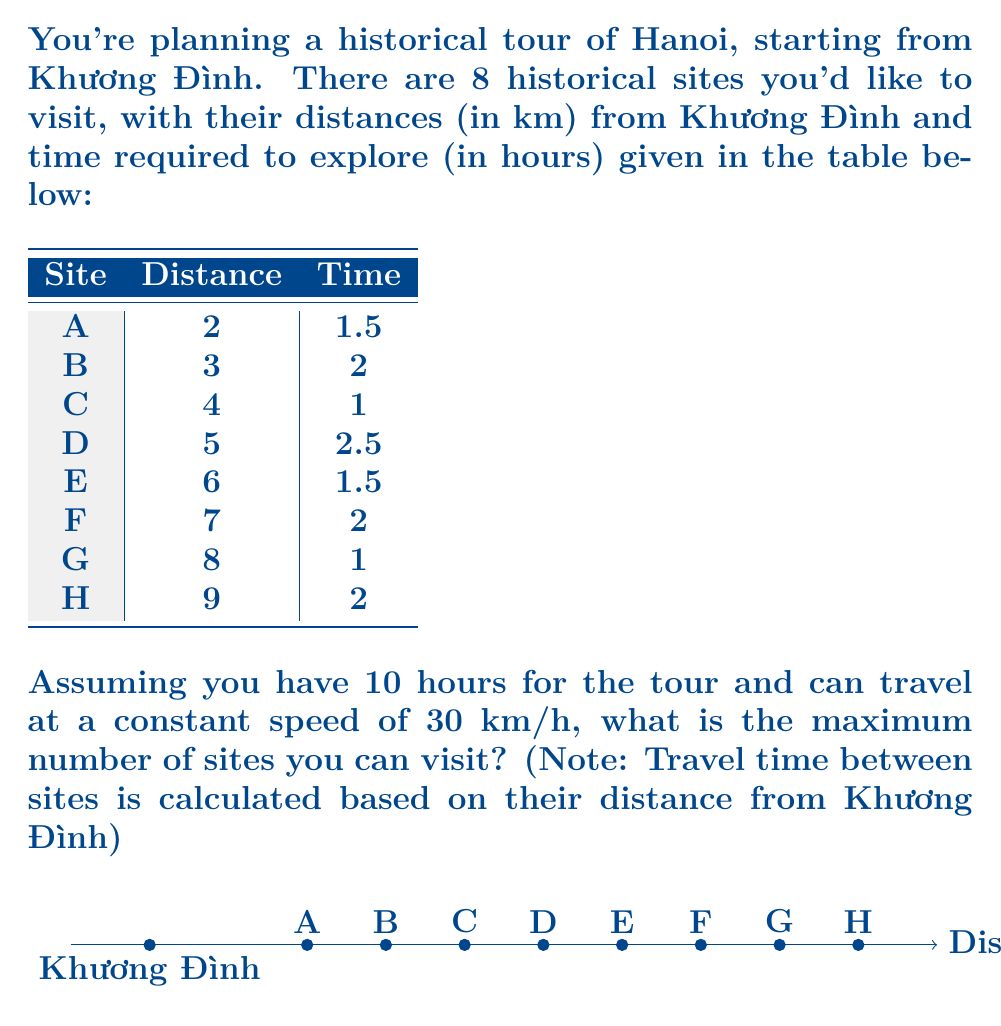Provide a solution to this math problem. Let's approach this step-by-step:

1) First, we need to calculate the total time for each site, including travel time:

   Travel time = Distance / Speed
   Total time = Travel time + Exploration time

   For each site:
   A: (2/30) + 1.5 = 1.57 hours
   B: (3/30) + 2 = 2.10 hours
   C: (4/30) + 1 = 1.13 hours
   D: (5/30) + 2.5 = 2.67 hours
   E: (6/30) + 1.5 = 1.70 hours
   F: (7/30) + 2 = 2.23 hours
   G: (8/30) + 1 = 1.27 hours
   H: (9/30) + 2 = 2.30 hours

2) Now, we need to maximize the number of sites visited within 10 hours. This is a knapsack problem, where we want to maximize the number of items (sites) within a weight limit (time).

3) The optimal strategy is to visit sites in order of increasing total time:

   C (1.13), G (1.27), A (1.57), E (1.70), B (2.10), F (2.23), H (2.30), D (2.67)

4) Let's add these up until we reach or exceed 10 hours:

   1.13 + 1.27 + 1.57 + 1.70 + 2.10 = 7.77 hours

5) Adding the next site (F) would bring us to 10 hours, exceeding our limit.

Therefore, the maximum number of sites that can be visited is 5.
Answer: 5 sites 